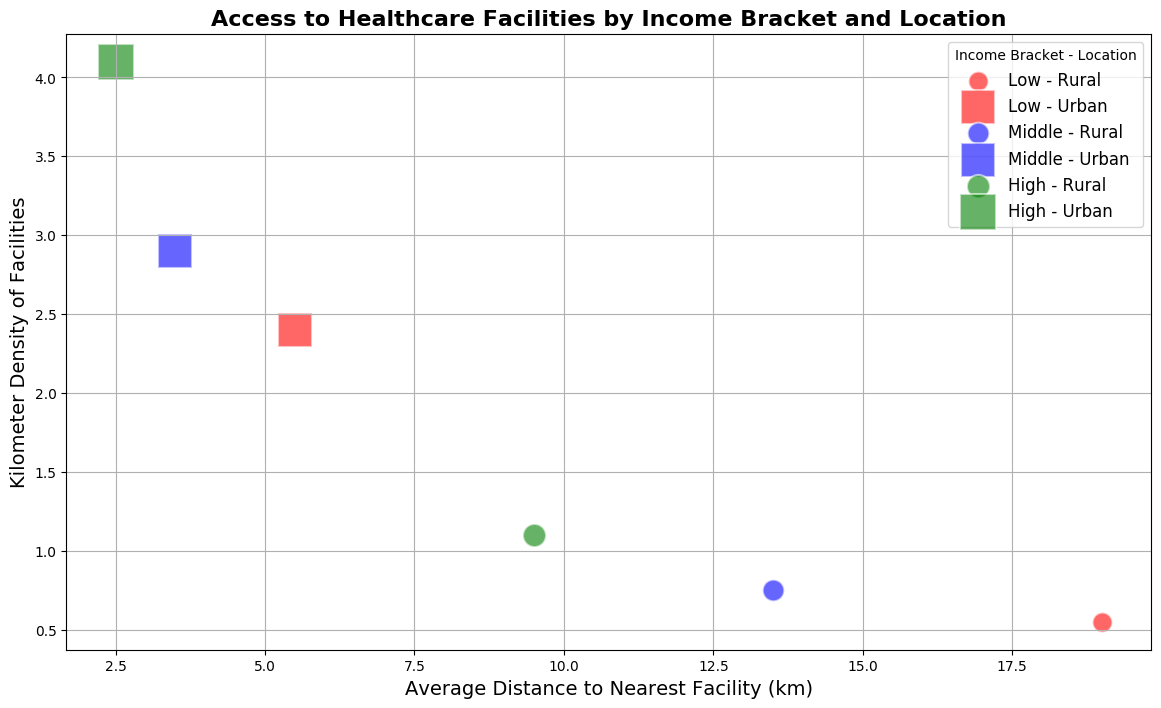Which income bracket has the largest population in rural areas? To find the income bracket with the largest population in rural areas, look at the size of the bubbles corresponding to rural locations in the colors representing each income bracket (Red for Low, Blue for Middle, Green for High). Compare these sizes for the largest one.
Answer: High What is the difference in the average distance to the nearest facility between all rural and urban locations? Calculate the average distance for rural (20+15+10+18+12+9)/6 and urban (5+3+2+6+4+3)/6. Subtract the rural average from the urban average.
Answer: 12.8 km Which category shows the highest kilometer density of facilities? Compare the heights of all bubbles on the vertical axis (Kilometer Density of Facilities). Look for the highest position bubble.
Answer: High-Urban Are low-income groups generally further away from healthcare facilities than high-income groups? Examine the horizontal positions of bubbles colored in Red (Low) and Green (High) on the chart. See if the red bubbles are mostly placed further to the right than the green ones.
Answer: Yes Which group tends to have larger bubble sizes in urban areas compared to rural areas? Look at each income bracket (color) and compare bubble sizes for urban (squares) and rural (circles) within those brackets. Identify the bracket where urban bubbles are consistently larger.
Answer: Low What is the combined population of middle-income groups in rural and urban areas? Find the bubble sizes for middle-income groups (Blue) and add the population values for rural (6000+6100) and urban (16000+15500).
Answer: 43,600 Which location type has a smaller average distance to the nearest facility for high-income groups? Compare the horizontal positions of Green bubbles (High) for rural (circles) and urban (squares). Note whether the urban green bubbles are positioned further left.
Answer: Urban What is the average kilometer density of facilities for low-income groups across both locations? Calculate the average of the densities for low-income groups (0.5, 2.5, 0.6, 2.3).
Answer: 1.475 Does the middle-income bracket in rural areas have a higher average distance to the nearest facility compared to high-income in rural areas? Compare the horizontal positions of Blue circles (Middle-Rural) and Green circles (High-Rural). Determine if Blue circles are positioned further right.
Answer: Yes Do urban areas have a more consistent kilometer density of facilities across different income brackets than rural areas? Observe the vertical distribution of all urban (squares) and rural (circles) bubbles across Red, Blue, and Green colors. See if the urban bubbles show less variation.
Answer: Yes 